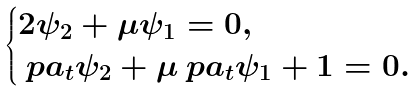<formula> <loc_0><loc_0><loc_500><loc_500>\begin{cases} 2 \psi _ { 2 } + \mu \psi _ { 1 } = 0 , \\ \ p a _ { t } \psi _ { 2 } + \mu \ p a _ { t } \psi _ { 1 } + 1 = 0 . \end{cases}</formula> 